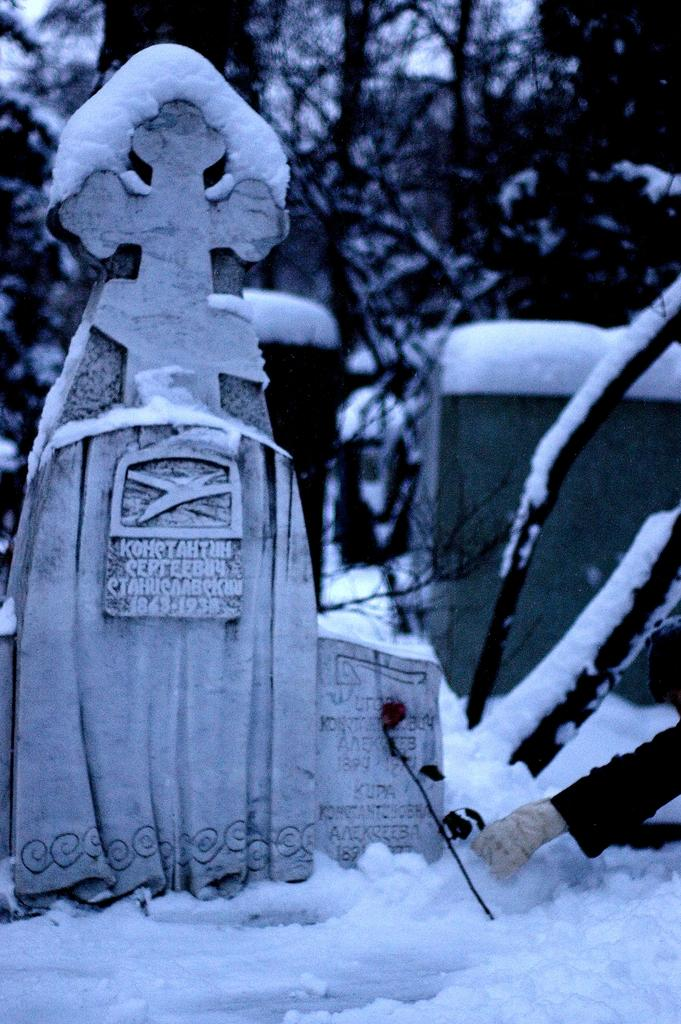What is the main subject in the foreground of the image? There is a headstone in the foreground of the image. What is the headstone resting on? The headstone is on the snow. What other object can be seen in the foreground of the image? There is a flower in the foreground of the image. What can be seen in the background of the image? There are objects and trees in the background of the image, and the snow is also visible. What type of cloud can be seen in the image? There is no cloud present in the image; it features a headstone on snow with a flower and objects in the background. 